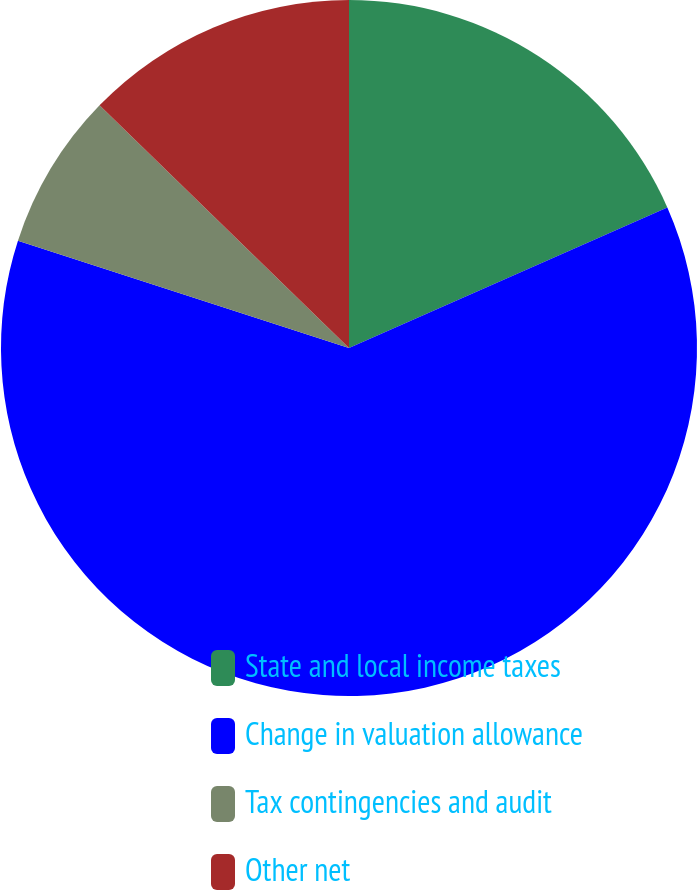Convert chart to OTSL. <chart><loc_0><loc_0><loc_500><loc_500><pie_chart><fcel>State and local income taxes<fcel>Change in valuation allowance<fcel>Tax contingencies and audit<fcel>Other net<nl><fcel>18.38%<fcel>61.61%<fcel>7.29%<fcel>12.72%<nl></chart> 